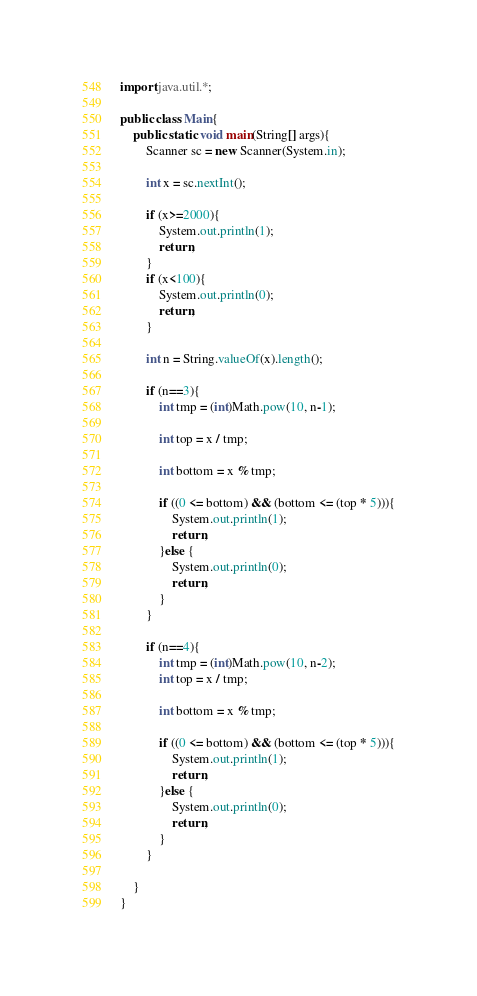Convert code to text. <code><loc_0><loc_0><loc_500><loc_500><_Java_>import java.util.*;

public class Main{
    public static void main(String[] args){
        Scanner sc = new Scanner(System.in);

        int x = sc.nextInt();

        if (x>=2000){
            System.out.println(1);
            return;
        }
        if (x<100){
            System.out.println(0);
            return;
        }

        int n = String.valueOf(x).length();

        if (n==3){
            int tmp = (int)Math.pow(10, n-1);

            int top = x / tmp;

            int bottom = x % tmp;

            if ((0 <= bottom) && (bottom <= (top * 5))){
                System.out.println(1);
                return;
            }else {
                System.out.println(0);
                return;
            }
        }

        if (n==4){
            int tmp = (int)Math.pow(10, n-2);
            int top = x / tmp;

            int bottom = x % tmp;

            if ((0 <= bottom) && (bottom <= (top * 5))){
                System.out.println(1);
                return;
            }else {
                System.out.println(0);
                return;
            }
        }

    }
}</code> 